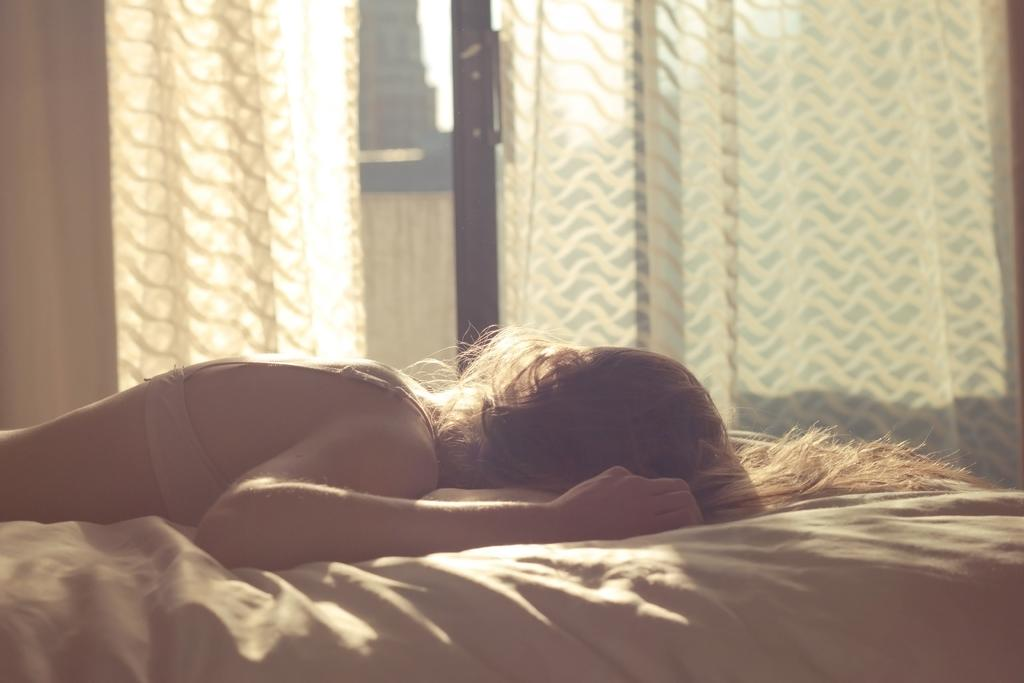What is the person in the image doing? The person is lying on the bed in the image. What can be seen on the windows in the image? There are curtains in the image. Can you describe any other objects present in the image? There are other objects present in the image, but their specific details are not mentioned in the provided facts. What type of cast is the person wearing on their leg in the image? There is no cast visible on the person's leg in the image. How many trays are being used by the passenger in the image? There is no passenger or tray present in the image. 